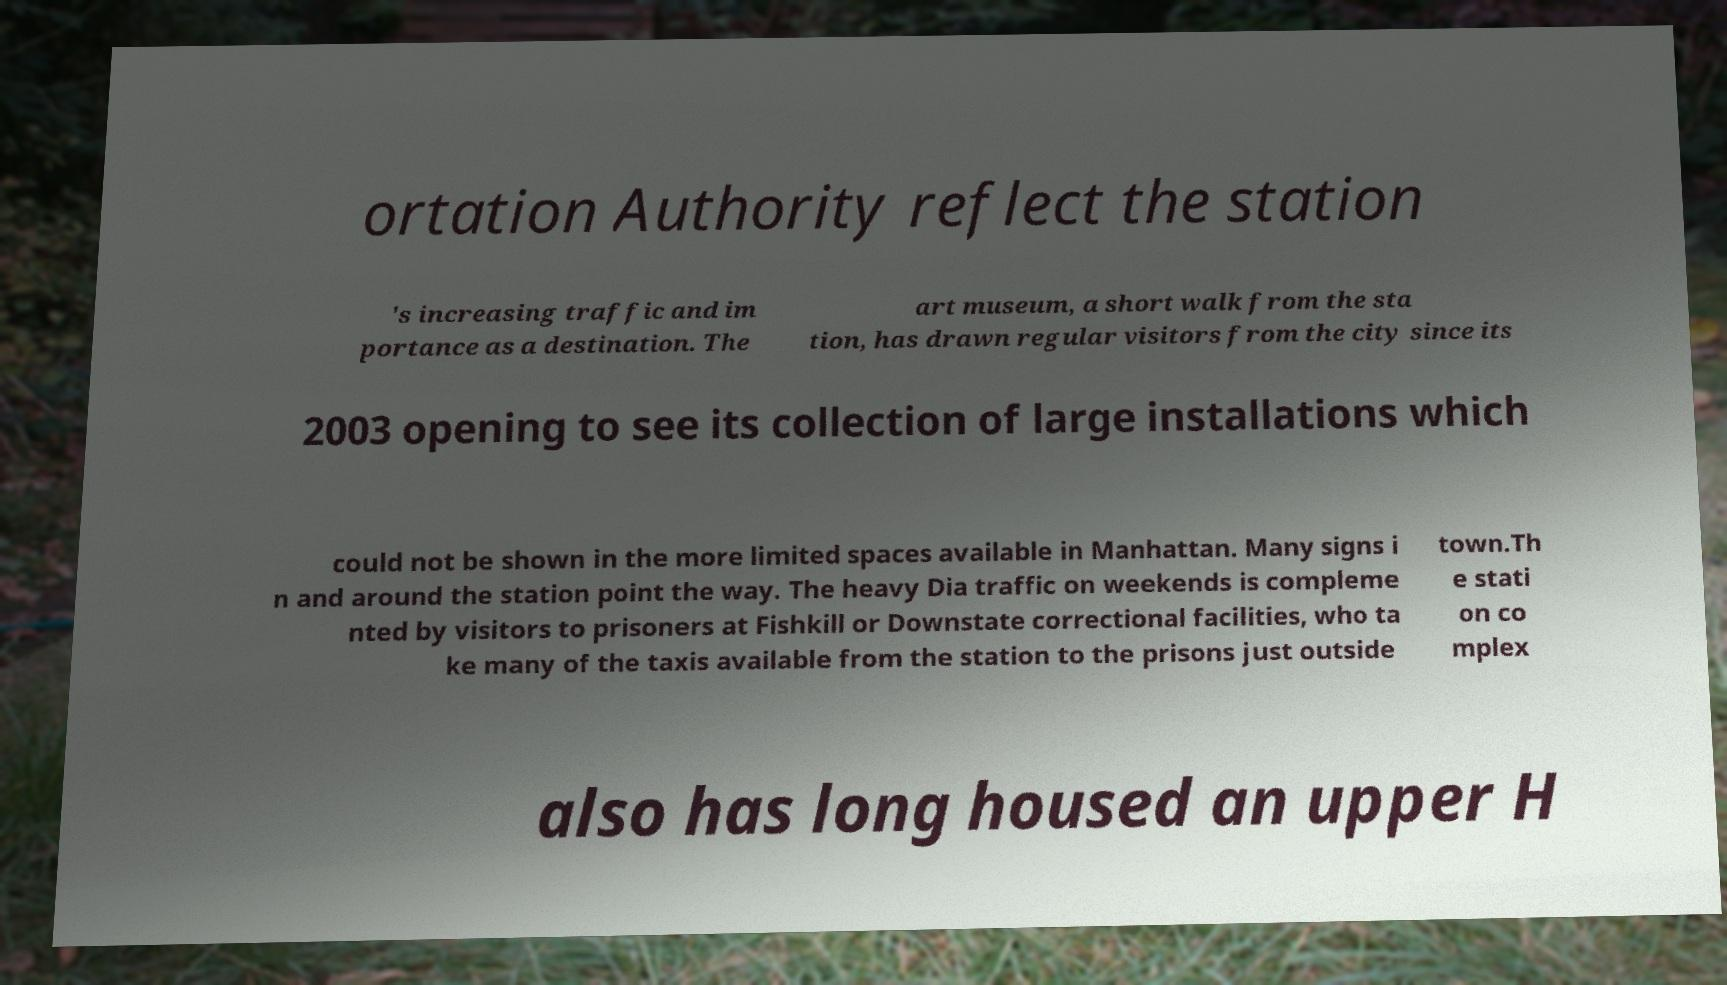I need the written content from this picture converted into text. Can you do that? ortation Authority reflect the station 's increasing traffic and im portance as a destination. The art museum, a short walk from the sta tion, has drawn regular visitors from the city since its 2003 opening to see its collection of large installations which could not be shown in the more limited spaces available in Manhattan. Many signs i n and around the station point the way. The heavy Dia traffic on weekends is compleme nted by visitors to prisoners at Fishkill or Downstate correctional facilities, who ta ke many of the taxis available from the station to the prisons just outside town.Th e stati on co mplex also has long housed an upper H 